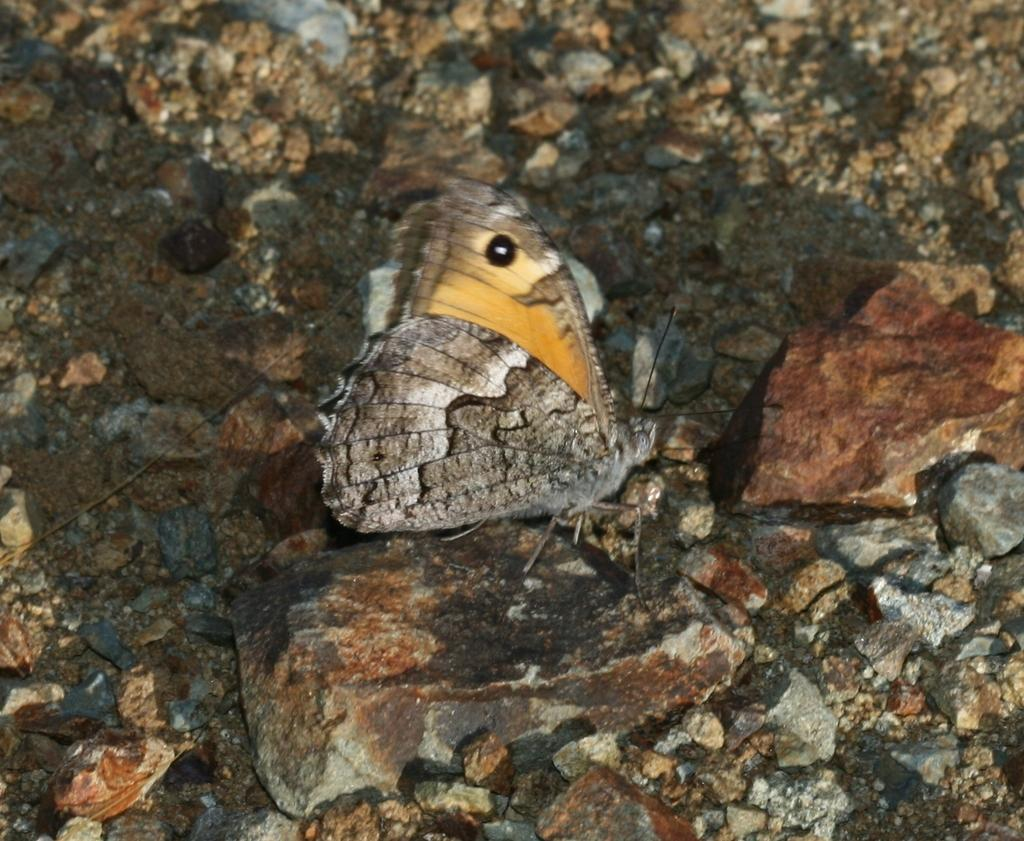What type of objects can be seen in the image? There are stones in the image. What other living creature can be seen in the image? There is a grey and yellow color insect in the image. What type of food is the insect eating in the image? There is no indication in the image that the insect is eating any food, so it cannot be determined from the picture. Can you tell me if the stones in the image have received approval from a governing body? There is no information about approval from a governing body for the stones in the image. 